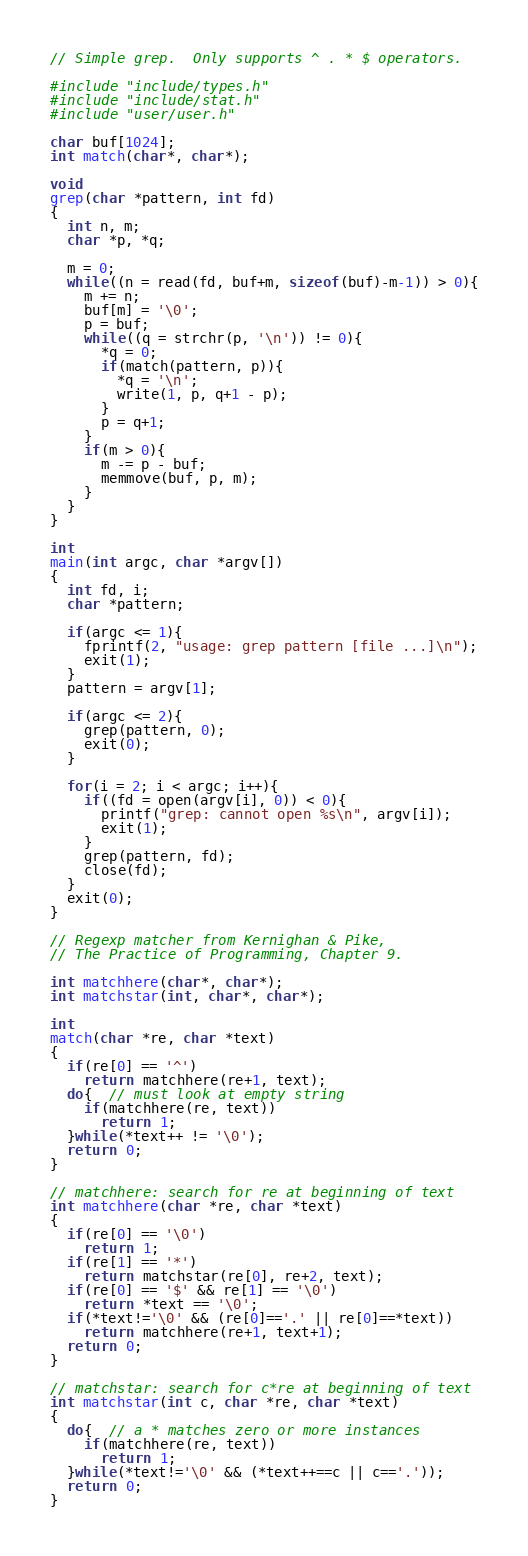<code> <loc_0><loc_0><loc_500><loc_500><_C_>// Simple grep.  Only supports ^ . * $ operators.

#include "include/types.h"
#include "include/stat.h"
#include "user/user.h"

char buf[1024];
int match(char*, char*);

void
grep(char *pattern, int fd)
{
  int n, m;
  char *p, *q;

  m = 0;
  while((n = read(fd, buf+m, sizeof(buf)-m-1)) > 0){
    m += n;
    buf[m] = '\0';
    p = buf;
    while((q = strchr(p, '\n')) != 0){
      *q = 0;
      if(match(pattern, p)){
        *q = '\n';
        write(1, p, q+1 - p);
      }
      p = q+1;
    }
    if(m > 0){
      m -= p - buf;
      memmove(buf, p, m);
    }
  }
}

int
main(int argc, char *argv[])
{
  int fd, i;
  char *pattern;

  if(argc <= 1){
    fprintf(2, "usage: grep pattern [file ...]\n");
    exit(1);
  }
  pattern = argv[1];

  if(argc <= 2){
    grep(pattern, 0);
    exit(0);
  }

  for(i = 2; i < argc; i++){
    if((fd = open(argv[i], 0)) < 0){
      printf("grep: cannot open %s\n", argv[i]);
      exit(1);
    }
    grep(pattern, fd);
    close(fd);
  }
  exit(0);
}

// Regexp matcher from Kernighan & Pike,
// The Practice of Programming, Chapter 9.

int matchhere(char*, char*);
int matchstar(int, char*, char*);

int
match(char *re, char *text)
{
  if(re[0] == '^')
    return matchhere(re+1, text);
  do{  // must look at empty string
    if(matchhere(re, text))
      return 1;
  }while(*text++ != '\0');
  return 0;
}

// matchhere: search for re at beginning of text
int matchhere(char *re, char *text)
{
  if(re[0] == '\0')
    return 1;
  if(re[1] == '*')
    return matchstar(re[0], re+2, text);
  if(re[0] == '$' && re[1] == '\0')
    return *text == '\0';
  if(*text!='\0' && (re[0]=='.' || re[0]==*text))
    return matchhere(re+1, text+1);
  return 0;
}

// matchstar: search for c*re at beginning of text
int matchstar(int c, char *re, char *text)
{
  do{  // a * matches zero or more instances
    if(matchhere(re, text))
      return 1;
  }while(*text!='\0' && (*text++==c || c=='.'));
  return 0;
}
</code> 